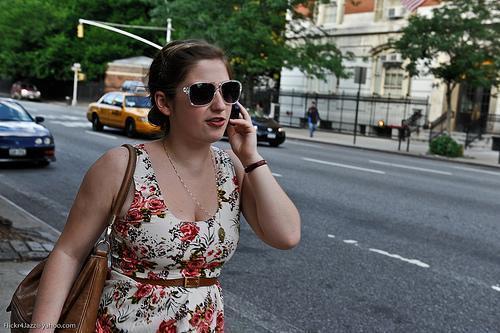How many people are walking on sidewalks?
Give a very brief answer. 2. How many watches is the woman wearing?
Give a very brief answer. 1. 